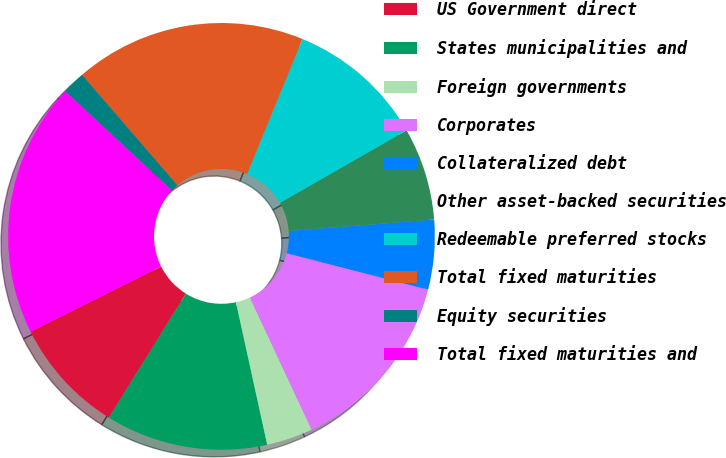Convert chart to OTSL. <chart><loc_0><loc_0><loc_500><loc_500><pie_chart><fcel>US Government direct<fcel>States municipalities and<fcel>Foreign governments<fcel>Corporates<fcel>Collateralized debt<fcel>Other asset-backed securities<fcel>Redeemable preferred stocks<fcel>Total fixed maturities<fcel>Equity securities<fcel>Total fixed maturities and<nl><fcel>8.78%<fcel>12.29%<fcel>3.51%<fcel>14.04%<fcel>5.27%<fcel>7.02%<fcel>10.53%<fcel>17.53%<fcel>1.76%<fcel>19.28%<nl></chart> 